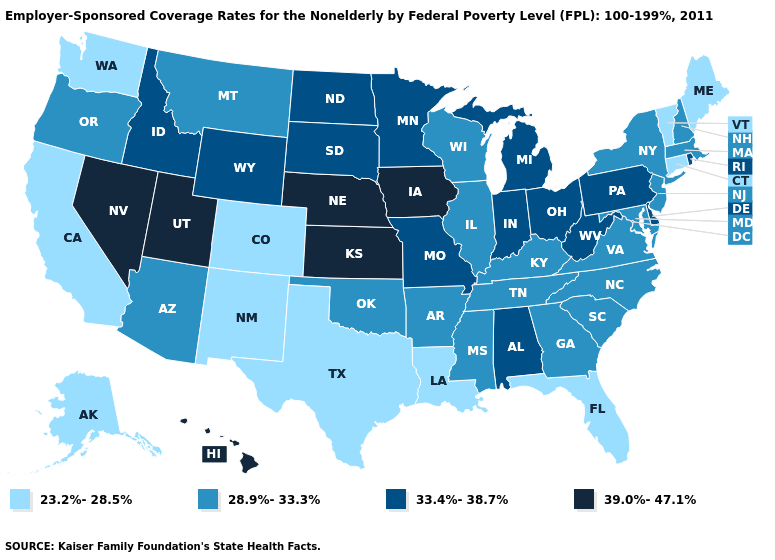Which states have the lowest value in the USA?
Write a very short answer. Alaska, California, Colorado, Connecticut, Florida, Louisiana, Maine, New Mexico, Texas, Vermont, Washington. Name the states that have a value in the range 28.9%-33.3%?
Answer briefly. Arizona, Arkansas, Georgia, Illinois, Kentucky, Maryland, Massachusetts, Mississippi, Montana, New Hampshire, New Jersey, New York, North Carolina, Oklahoma, Oregon, South Carolina, Tennessee, Virginia, Wisconsin. Does California have the lowest value in the USA?
Concise answer only. Yes. What is the value of Washington?
Concise answer only. 23.2%-28.5%. What is the value of Kentucky?
Keep it brief. 28.9%-33.3%. Does Maine have the highest value in the Northeast?
Answer briefly. No. What is the value of Pennsylvania?
Short answer required. 33.4%-38.7%. What is the value of Delaware?
Give a very brief answer. 33.4%-38.7%. Name the states that have a value in the range 23.2%-28.5%?
Give a very brief answer. Alaska, California, Colorado, Connecticut, Florida, Louisiana, Maine, New Mexico, Texas, Vermont, Washington. Which states have the lowest value in the USA?
Write a very short answer. Alaska, California, Colorado, Connecticut, Florida, Louisiana, Maine, New Mexico, Texas, Vermont, Washington. Name the states that have a value in the range 39.0%-47.1%?
Quick response, please. Hawaii, Iowa, Kansas, Nebraska, Nevada, Utah. Name the states that have a value in the range 39.0%-47.1%?
Keep it brief. Hawaii, Iowa, Kansas, Nebraska, Nevada, Utah. Does Arizona have a lower value than Ohio?
Write a very short answer. Yes. What is the value of Iowa?
Give a very brief answer. 39.0%-47.1%. Does Idaho have the highest value in the West?
Write a very short answer. No. 